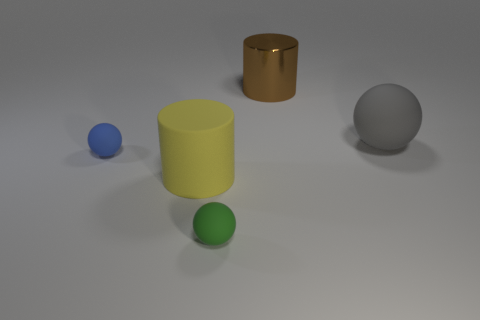Add 4 big brown rubber balls. How many objects exist? 9 Subtract all balls. How many objects are left? 2 Subtract 1 gray balls. How many objects are left? 4 Subtract all small matte balls. Subtract all big yellow cylinders. How many objects are left? 2 Add 2 brown shiny objects. How many brown shiny objects are left? 3 Add 3 big gray matte cylinders. How many big gray matte cylinders exist? 3 